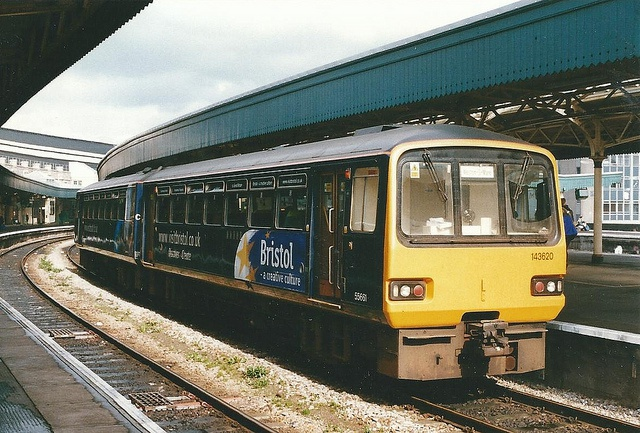Describe the objects in this image and their specific colors. I can see train in black, gray, khaki, and darkgray tones, people in black, darkblue, navy, and gray tones, and people in black and darkgreen tones in this image. 